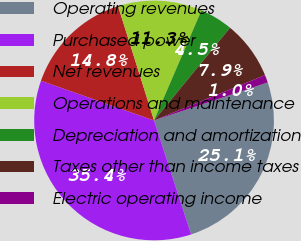Convert chart to OTSL. <chart><loc_0><loc_0><loc_500><loc_500><pie_chart><fcel>Operating revenues<fcel>Purchased power<fcel>Net revenues<fcel>Operations and maintenance<fcel>Depreciation and amortization<fcel>Taxes other than income taxes<fcel>Electric operating income<nl><fcel>25.13%<fcel>35.38%<fcel>14.77%<fcel>11.33%<fcel>4.46%<fcel>7.9%<fcel>1.03%<nl></chart> 